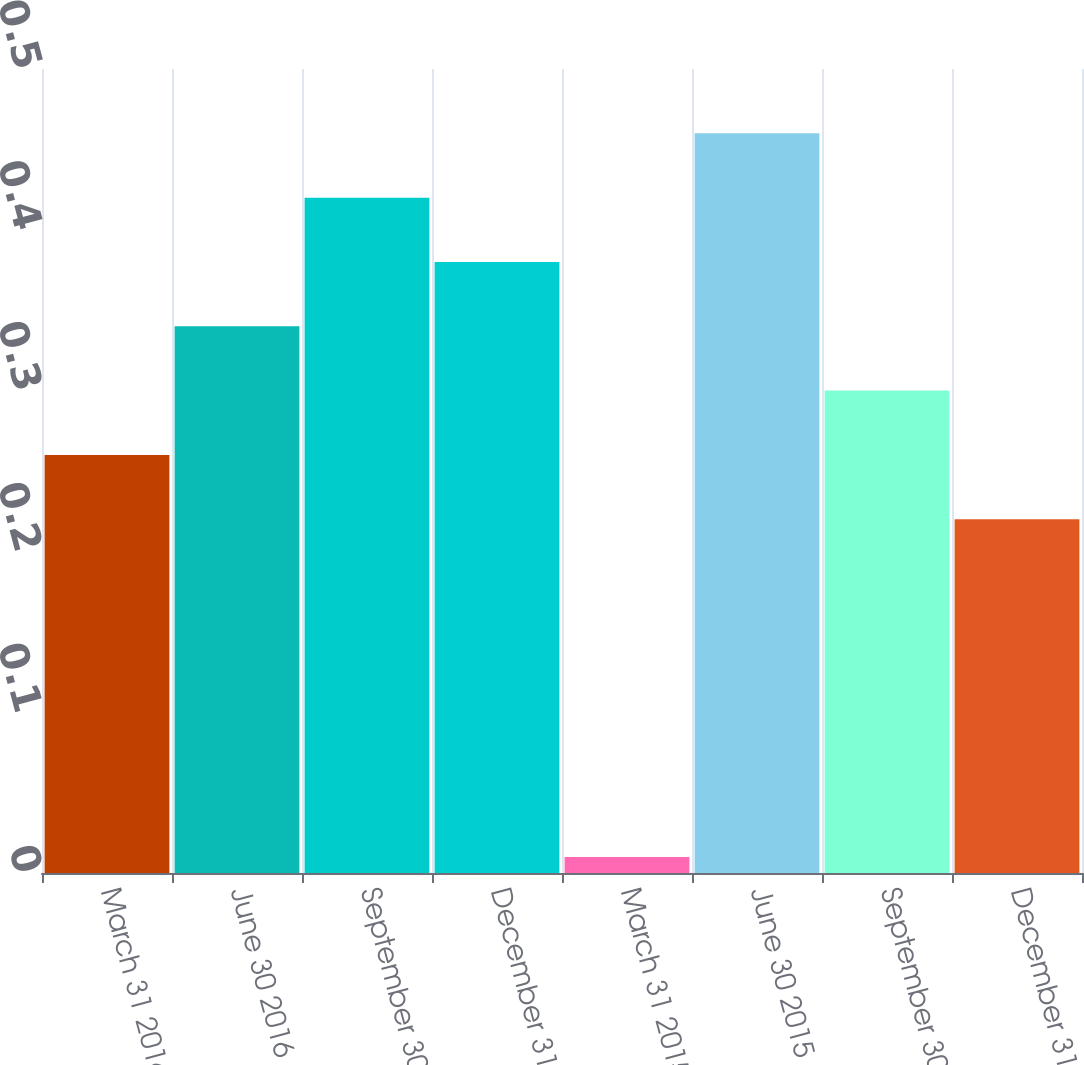Convert chart. <chart><loc_0><loc_0><loc_500><loc_500><bar_chart><fcel>March 31 2016<fcel>June 30 2016<fcel>September 30 2016<fcel>December 31 2016<fcel>March 31 2015<fcel>June 30 2015<fcel>September 30 2015<fcel>December 31 2015<nl><fcel>0.26<fcel>0.34<fcel>0.42<fcel>0.38<fcel>0.01<fcel>0.46<fcel>0.3<fcel>0.22<nl></chart> 